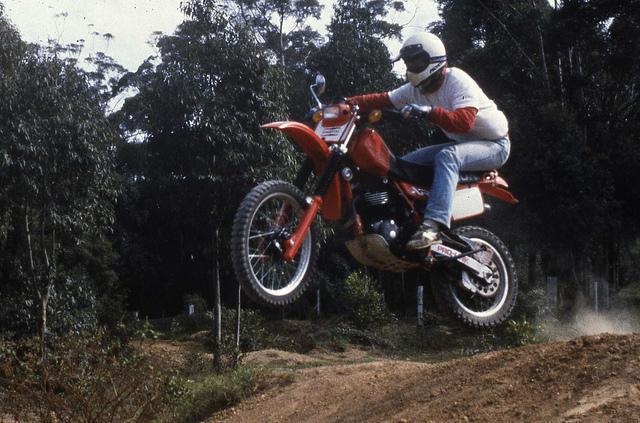How many zebras are in this picture?
Give a very brief answer. 0. 